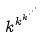<formula> <loc_0><loc_0><loc_500><loc_500>k ^ { k ^ { k ^ { \cdot ^ { \cdot ^ { \cdot } } } } }</formula> 